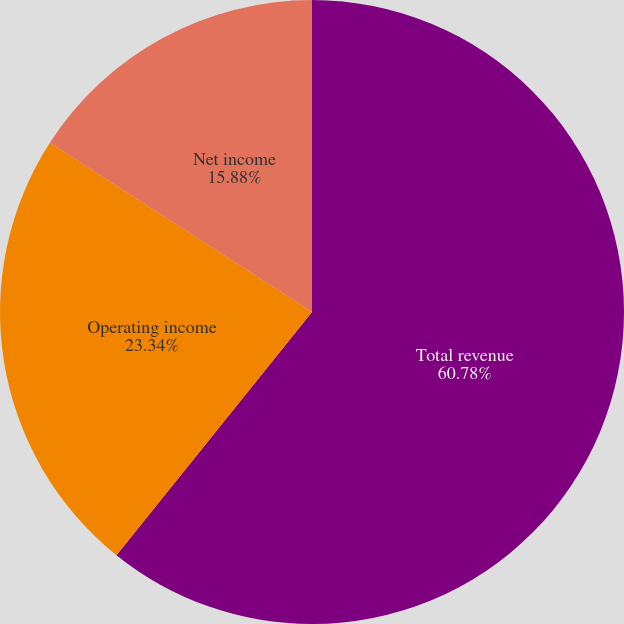Convert chart to OTSL. <chart><loc_0><loc_0><loc_500><loc_500><pie_chart><fcel>Total revenue<fcel>Operating income<fcel>Net income<nl><fcel>60.78%<fcel>23.34%<fcel>15.88%<nl></chart> 